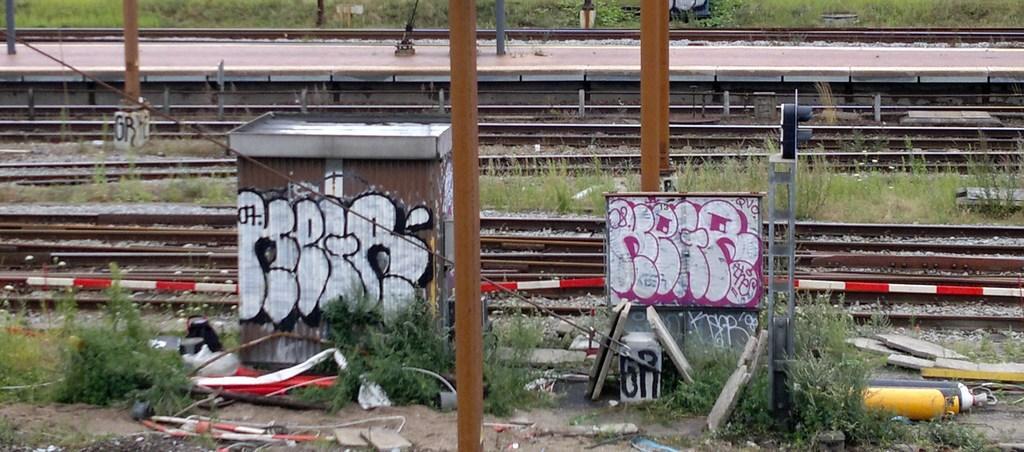Can you describe this image briefly? Here I can see a box, board, few metal objects are placed on the ground and also there are some plants. Behind there are some railway tracks. In the background there is a platform. 